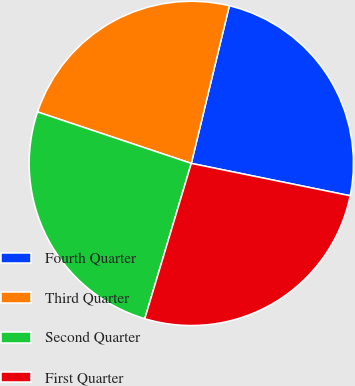Convert chart to OTSL. <chart><loc_0><loc_0><loc_500><loc_500><pie_chart><fcel>Fourth Quarter<fcel>Third Quarter<fcel>Second Quarter<fcel>First Quarter<nl><fcel>24.43%<fcel>23.63%<fcel>25.51%<fcel>26.43%<nl></chart> 